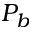<formula> <loc_0><loc_0><loc_500><loc_500>P _ { b }</formula> 